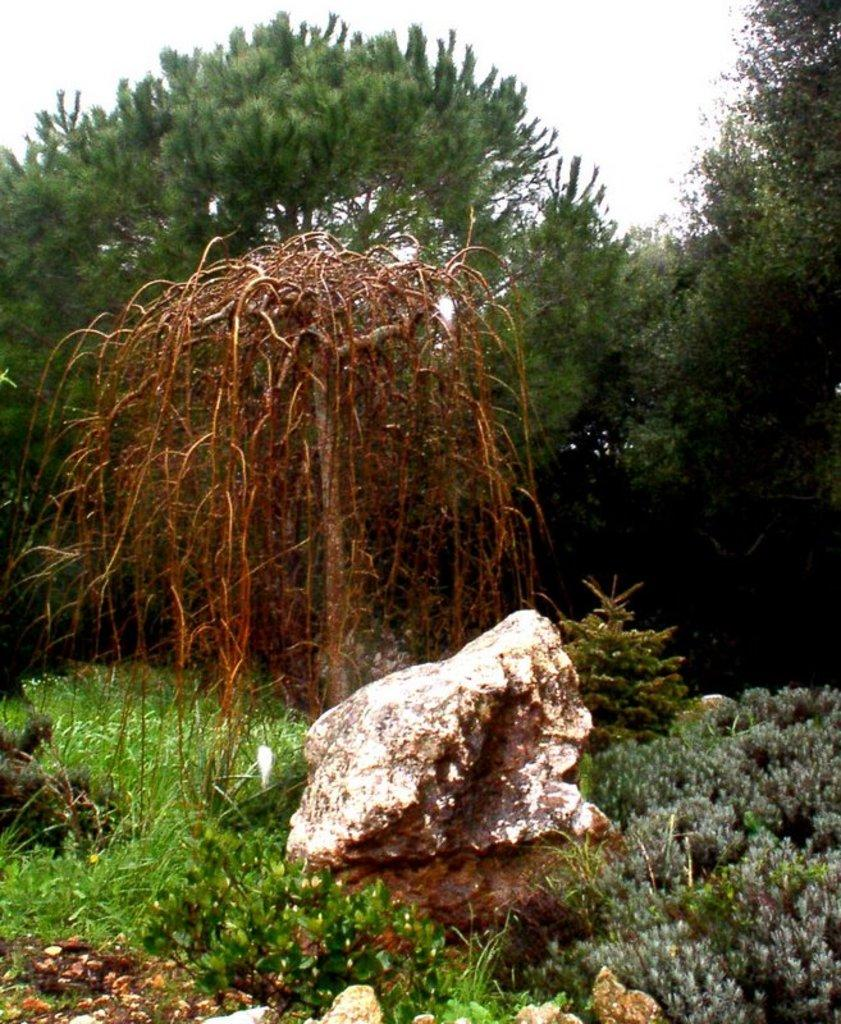What type of vegetation is on the ground in the image? There are plants on the ground in the image. What other object can be seen on the ground in the image? There is a rock on the ground in the image. What can be seen in the distance in the image? There are trees visible in the background of the image. What type of apparel is the rock wearing in the image? R: There is no apparel present in the image, as the rock is an inanimate object and does not wear clothing. 